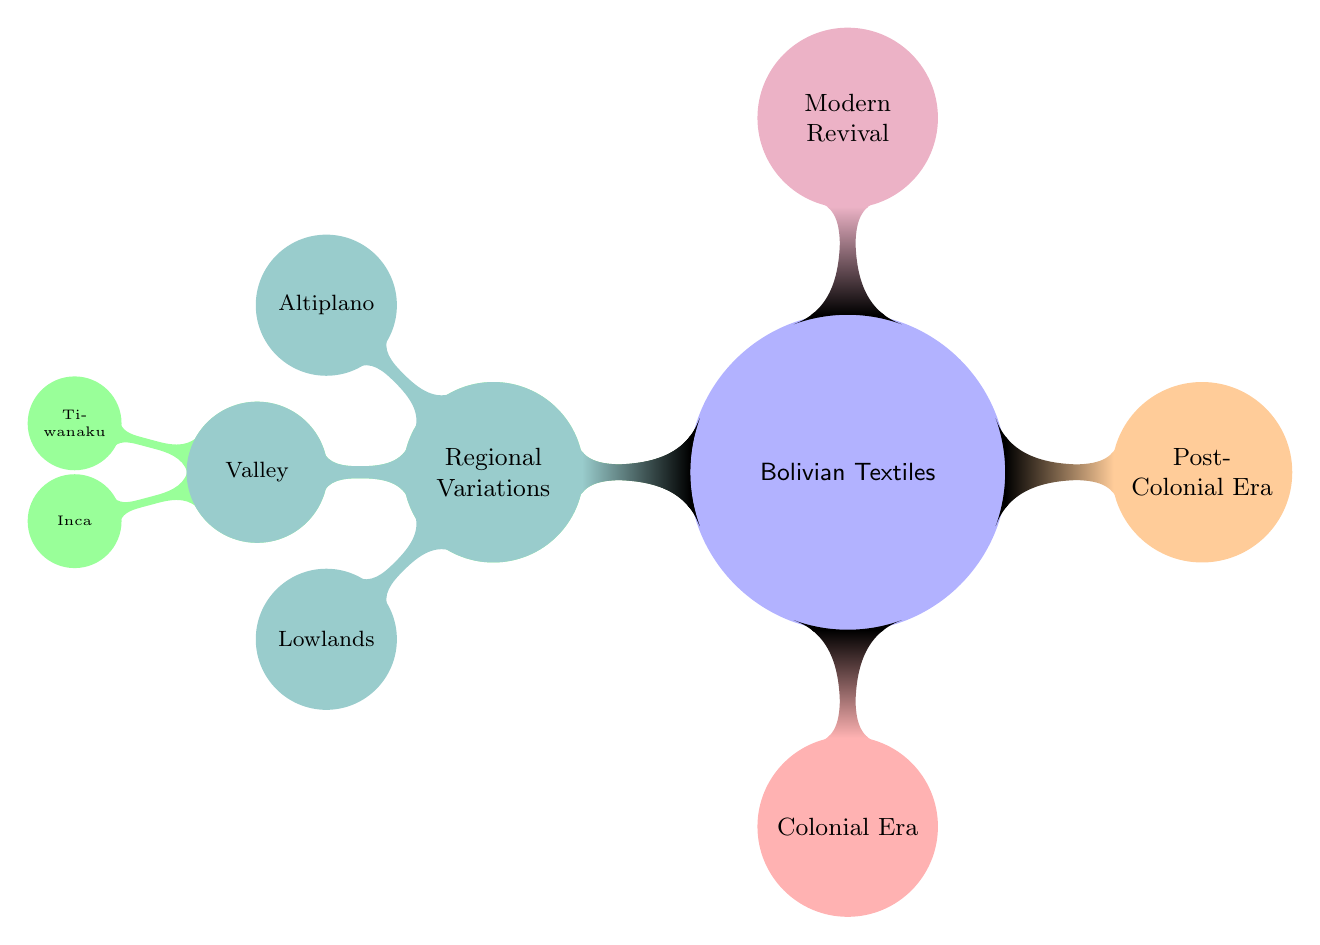What's the top-level category in the diagram? The top-level category in the diagram is "Bolivian Textiles". This is identified by observing that it is the first node from which all other categories branch out.
Answer: Bolivian Textiles How many main eras are represented in the diagram? The diagram shows four main eras: Pre-Colonial Era, Colonial Era, Post-Colonial Era, and Modern Revival. Counting these nodes gives a total of four main categories.
Answer: 4 What are the two cultures mentioned under the Pre-Colonial Era? The two cultures mentioned are Tiwanaku and Inca. These are listed as child nodes under the Andean Cultures node, making them easy to identify.
Answer: Tiwanaku, Inca Which region is associated with the Altiplano? The "Altiplano" is associated with the "Regional Variations" section of the diagram. It is listed as one of the regions that illustrate diversity within Bolivian textiles.
Answer: Regional Variations Is there a direct relationship between the Colonial Era and the Modern Revival? No, there is no direct relationship indicated in the diagram between the Colonial Era and the Modern Revival. They are separate nodes with no linking lines or relationships shown.
Answer: No How many regional variations are noted in the diagram? The diagram notes three regional variations: Altiplano, Valley, and Lowlands. This can be determined by counting the child nodes under the Regional Variations node.
Answer: 3 Which cultural group is specifically listed first in the Pre-Colonial Era? The cultural group specifically listed first in the Pre-Colonial Era is "Andean Cultures". This is evident as it is the first child node under the Pre-Colonial Era.
Answer: Andean Cultures What color represents the Colonial Era in the diagram? The color representing the Colonial Era is red. This can be seen by noting the color coding provided for each main category in the diagram.
Answer: Red What is the main focus of the diagram? The main focus of the diagram is to illustrate the evolution of fabric patterns and techniques in Bolivian textiles across different historical eras and regions. This can be inferred from the title "History of Bolivian Textiles" and the outlined categories.
Answer: Evolution of fabric patterns and techniques 